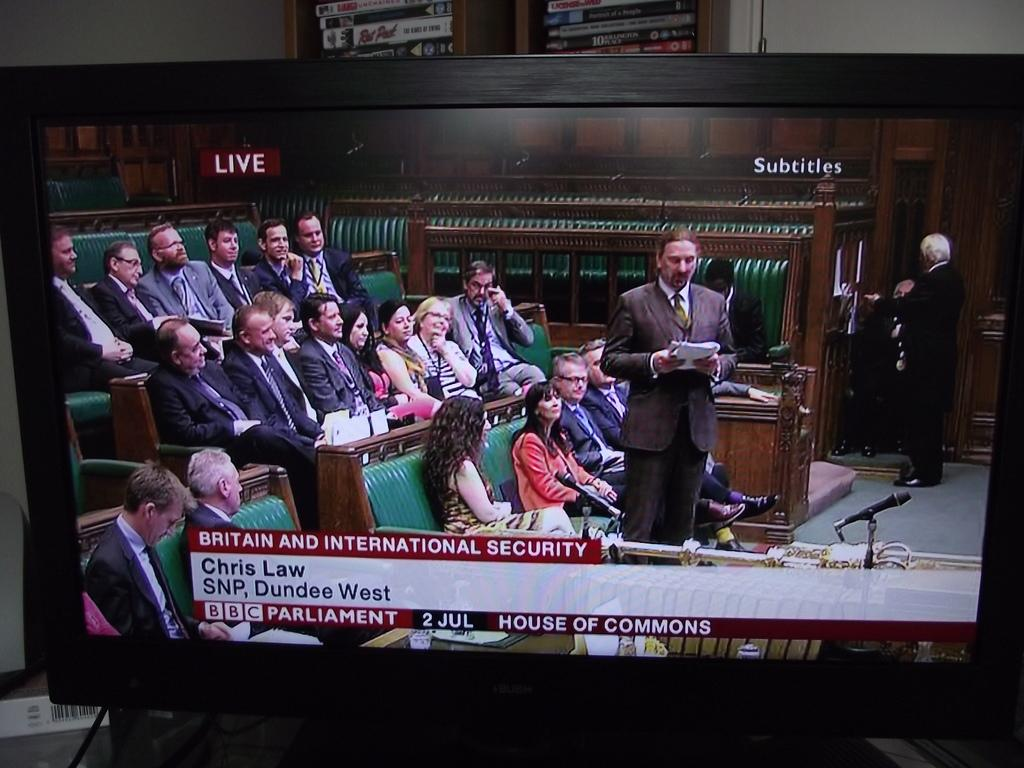<image>
Present a compact description of the photo's key features. A television turned to BBC that is showing Britain and International Security. 